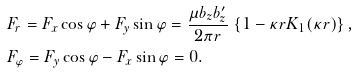<formula> <loc_0><loc_0><loc_500><loc_500>& F _ { r } = F _ { x } \cos \varphi + F _ { y } \sin \varphi = \frac { \mu b _ { z } b ^ { \prime } _ { z } } { 2 \pi r } \, \left \{ 1 - \kappa r K _ { 1 } ( \kappa r ) \right \} , \\ & F _ { \varphi } = F _ { y } \cos \varphi - F _ { x } \sin \varphi = 0 .</formula> 